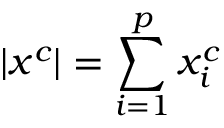<formula> <loc_0><loc_0><loc_500><loc_500>| x ^ { c } | = \sum _ { i = 1 } ^ { p } x _ { i } ^ { c }</formula> 